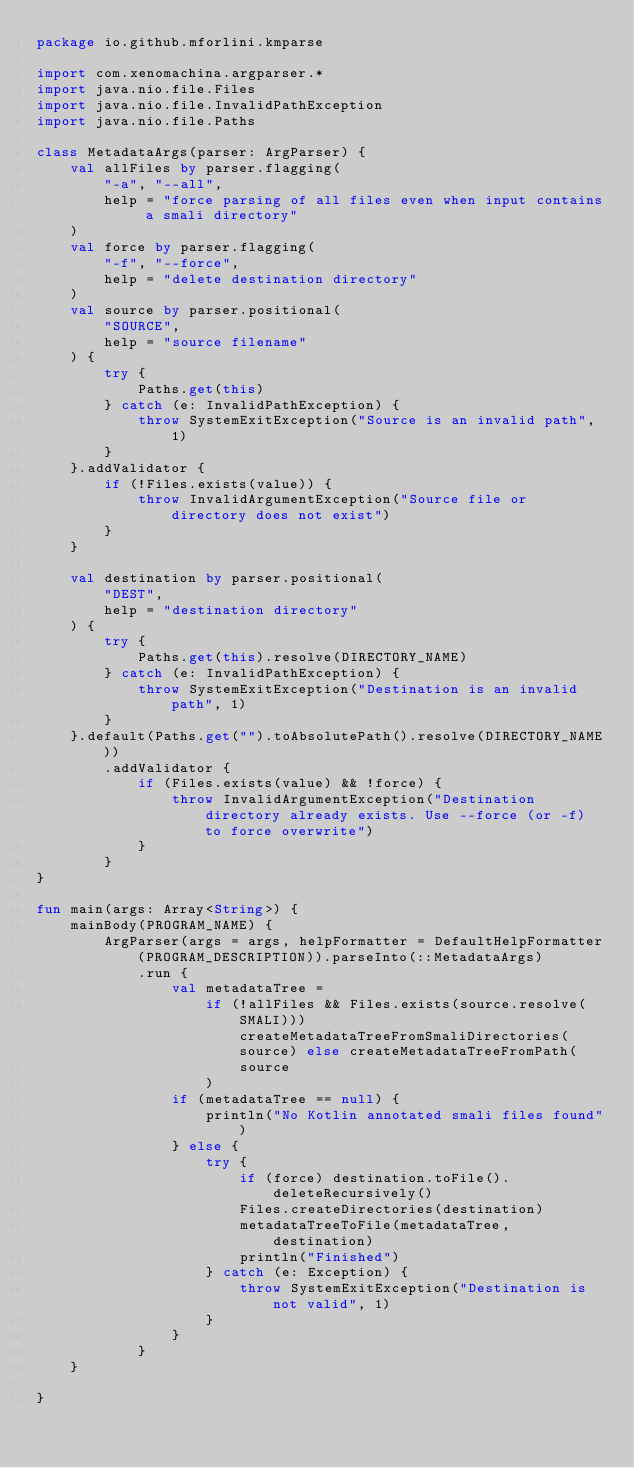<code> <loc_0><loc_0><loc_500><loc_500><_Kotlin_>package io.github.mforlini.kmparse

import com.xenomachina.argparser.*
import java.nio.file.Files
import java.nio.file.InvalidPathException
import java.nio.file.Paths

class MetadataArgs(parser: ArgParser) {
    val allFiles by parser.flagging(
        "-a", "--all",
        help = "force parsing of all files even when input contains a smali directory"
    )
    val force by parser.flagging(
        "-f", "--force",
        help = "delete destination directory"
    )
    val source by parser.positional(
        "SOURCE",
        help = "source filename"
    ) {
        try {
            Paths.get(this)
        } catch (e: InvalidPathException) {
            throw SystemExitException("Source is an invalid path", 1)
        }
    }.addValidator {
        if (!Files.exists(value)) {
            throw InvalidArgumentException("Source file or directory does not exist")
        }
    }

    val destination by parser.positional(
        "DEST",
        help = "destination directory"
    ) {
        try {
            Paths.get(this).resolve(DIRECTORY_NAME)
        } catch (e: InvalidPathException) {
            throw SystemExitException("Destination is an invalid path", 1)
        }
    }.default(Paths.get("").toAbsolutePath().resolve(DIRECTORY_NAME))
        .addValidator {
            if (Files.exists(value) && !force) {
                throw InvalidArgumentException("Destination directory already exists. Use --force (or -f) to force overwrite")
            }
        }
}

fun main(args: Array<String>) {
    mainBody(PROGRAM_NAME) {
        ArgParser(args = args, helpFormatter = DefaultHelpFormatter(PROGRAM_DESCRIPTION)).parseInto(::MetadataArgs)
            .run {
                val metadataTree =
                    if (!allFiles && Files.exists(source.resolve(SMALI))) createMetadataTreeFromSmaliDirectories(source) else createMetadataTreeFromPath(
                        source
                    )
                if (metadataTree == null) {
                    println("No Kotlin annotated smali files found")
                } else {
                    try {
                        if (force) destination.toFile().deleteRecursively()
                        Files.createDirectories(destination)
                        metadataTreeToFile(metadataTree, destination)
                        println("Finished")
                    } catch (e: Exception) {
                        throw SystemExitException("Destination is not valid", 1)
                    }
                }
            }
    }

}</code> 